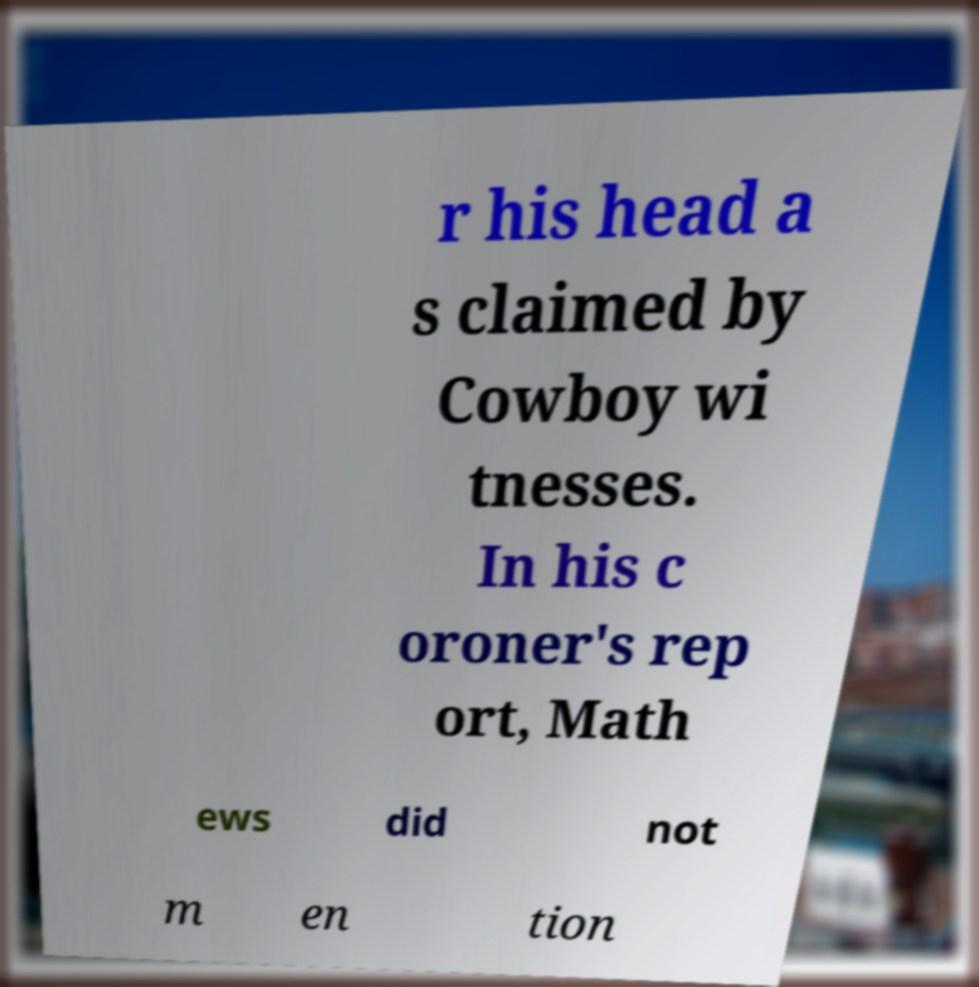Could you assist in decoding the text presented in this image and type it out clearly? r his head a s claimed by Cowboy wi tnesses. In his c oroner's rep ort, Math ews did not m en tion 